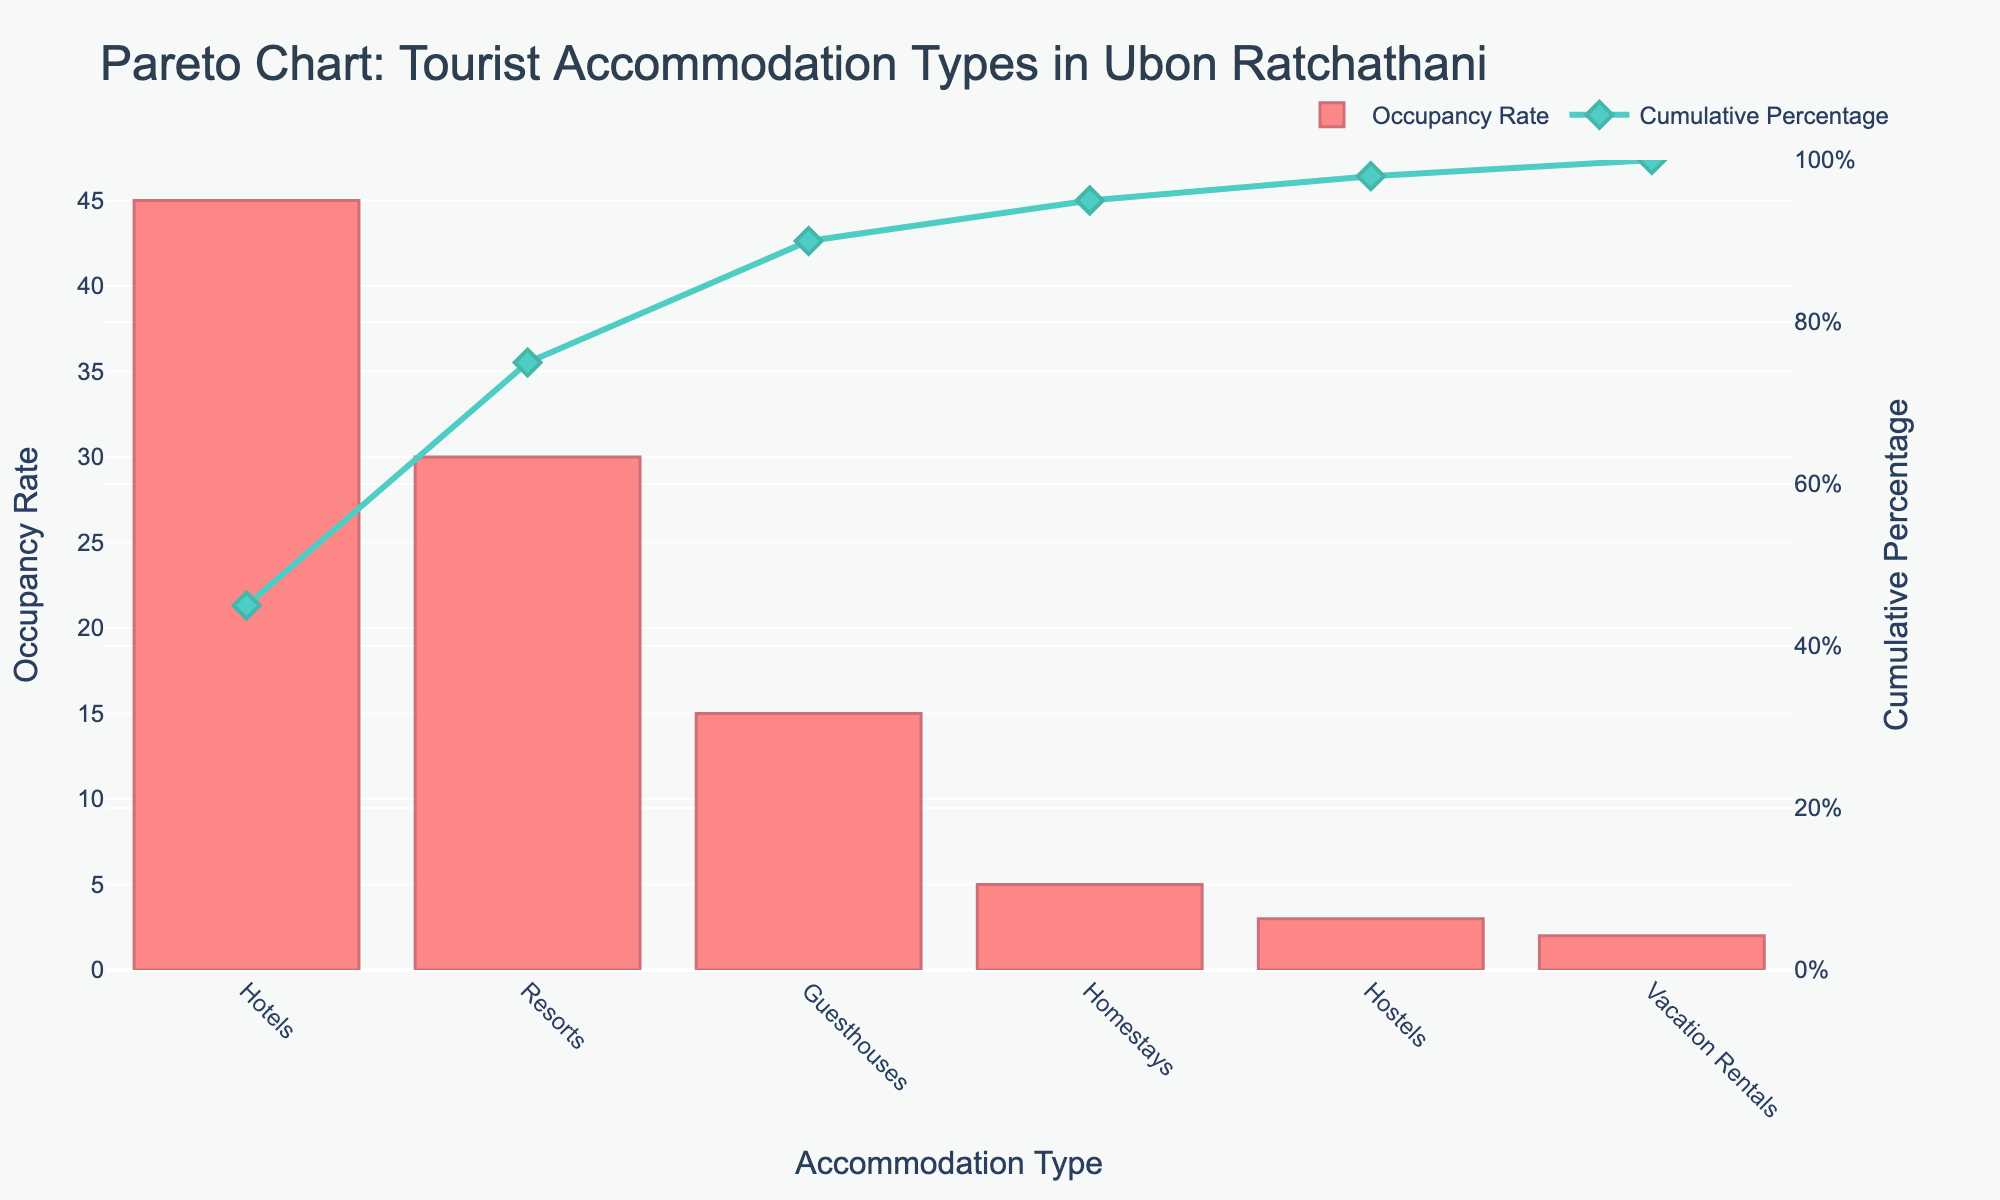What is the title of the plot? The title is clearly displayed at the top of the plot. It describes the contents of the chart and provides context to the viewers.
Answer: Pareto Chart: Tourist Accommodation Types in Ubon Ratchathani What is the highest occupancy rate among the accommodation types? By examining the bar heights, the tallest bar indicates the highest occupancy rate.
Answer: 45% Which accommodation type has the lowest occupancy rate? The shortest bar shows the accommodation type with the lowest occupancy rate.
Answer: Vacation Rentals What is the cumulative percentage at the third data point? The cumulative percentage line passes through each data point. By looking at the third point on the x-axis, trace upward to the line to find the cumulative percentage.
Answer: 90% What is the total percentage for Guesthouses and Homestays combined? Locate the bars for Guesthouses and Homestays and sum their occupancy rates: 15 + 5 = 20. Therefore, the combined total is 20%.
Answer: 20% Which accommodation type contributes the most to the cumulative percentage above 50%? Locate the cumulative percentage line and find the point where it surpasses 50%. Identify which accommodation type's bar intersects closest before this threshold is crossed.
Answer: Resorts By how much does the occupancy rate of Hotels exceed that of Hostels? Subtract the occupancy rate of Hostels from that of Hotels: 45 - 3 = 42.
Answer: 42% Which three accommodation types together make up more than 90% of the cumulative percentage? Look at the cumulative percentage line and find when it surpasses 90%. The accommodation types before this threshold will sum together to give more than 90%.
Answer: Hotels, Resorts, Guesthouses What is the range of occupancy rates for the accommodation types? Subtract the smallest occupancy rate from the largest: 45 - 2 = 43.
Answer: 43% What is the percentage difference between Resorts and Guesthouses? Subtract the occupancy rate of Guesthouses from Resorts: 30 - 15 = 15. Calculate the percentage difference relative to Resorts: (15/30) * 100 = 50%.
Answer: 50% 